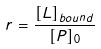Convert formula to latex. <formula><loc_0><loc_0><loc_500><loc_500>r = \frac { [ L ] _ { b o u n d } } { [ P ] _ { 0 } }</formula> 